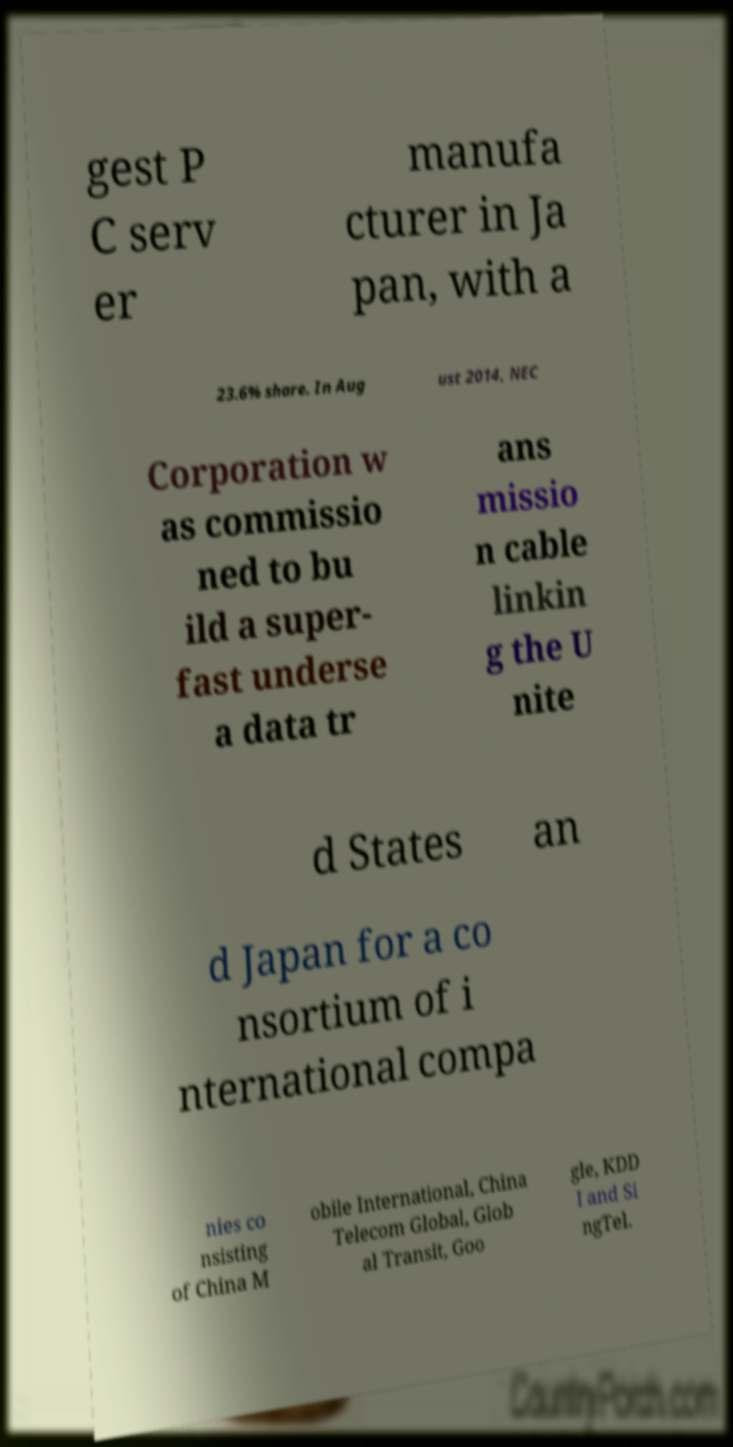Please read and relay the text visible in this image. What does it say? gest P C serv er manufa cturer in Ja pan, with a 23.6% share. In Aug ust 2014, NEC Corporation w as commissio ned to bu ild a super- fast underse a data tr ans missio n cable linkin g the U nite d States an d Japan for a co nsortium of i nternational compa nies co nsisting of China M obile International, China Telecom Global, Glob al Transit, Goo gle, KDD I and Si ngTel. 